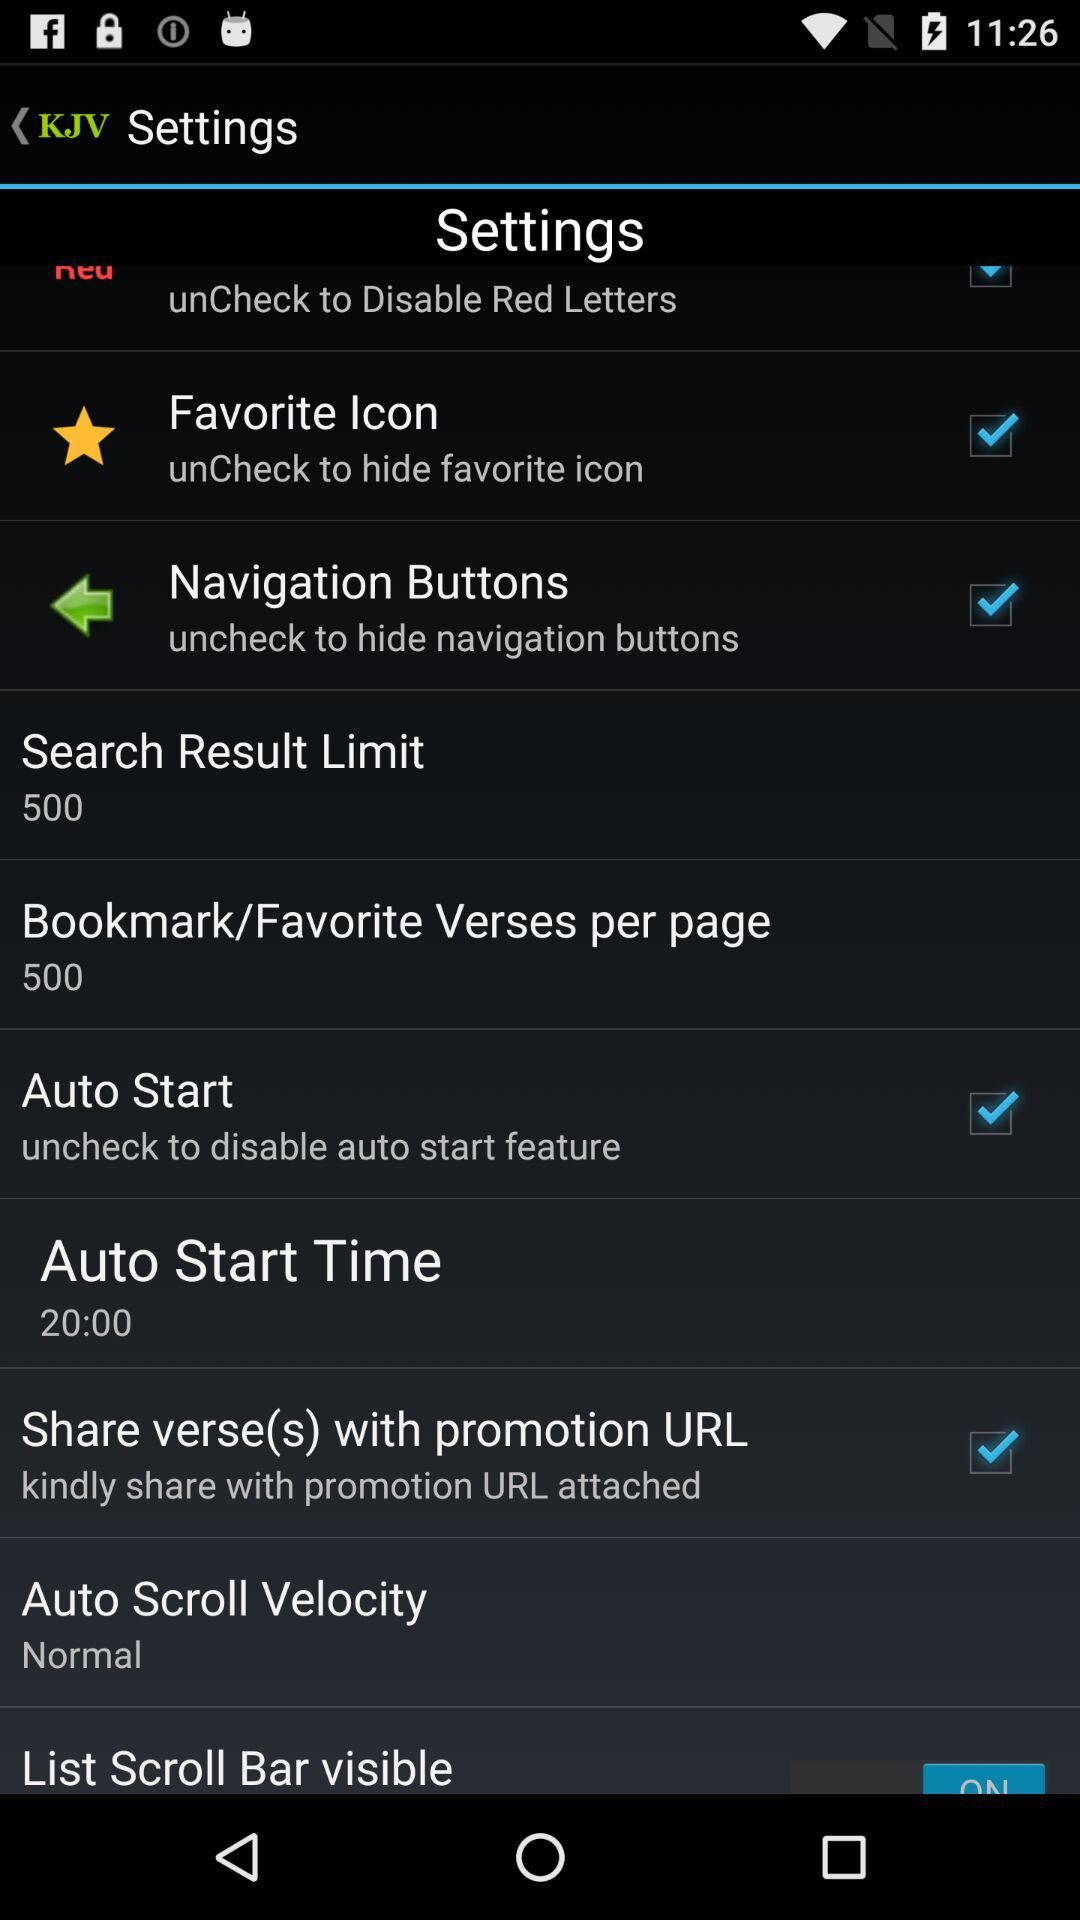What is the "Search Result Limit"? The "Search Result Limit" is 500. 